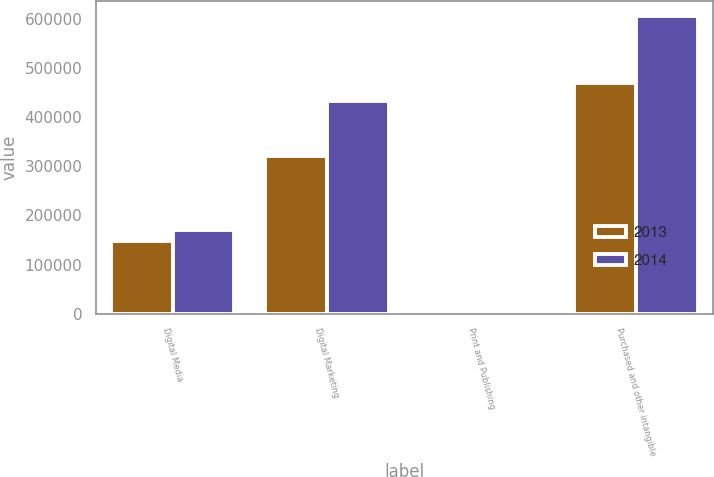Convert chart. <chart><loc_0><loc_0><loc_500><loc_500><stacked_bar_chart><ecel><fcel>Digital Media<fcel>Digital Marketing<fcel>Print and Publishing<fcel>Purchased and other intangible<nl><fcel>2013<fcel>147182<fcel>321086<fcel>1394<fcel>469662<nl><fcel>2014<fcel>170213<fcel>433245<fcel>1796<fcel>605254<nl></chart> 